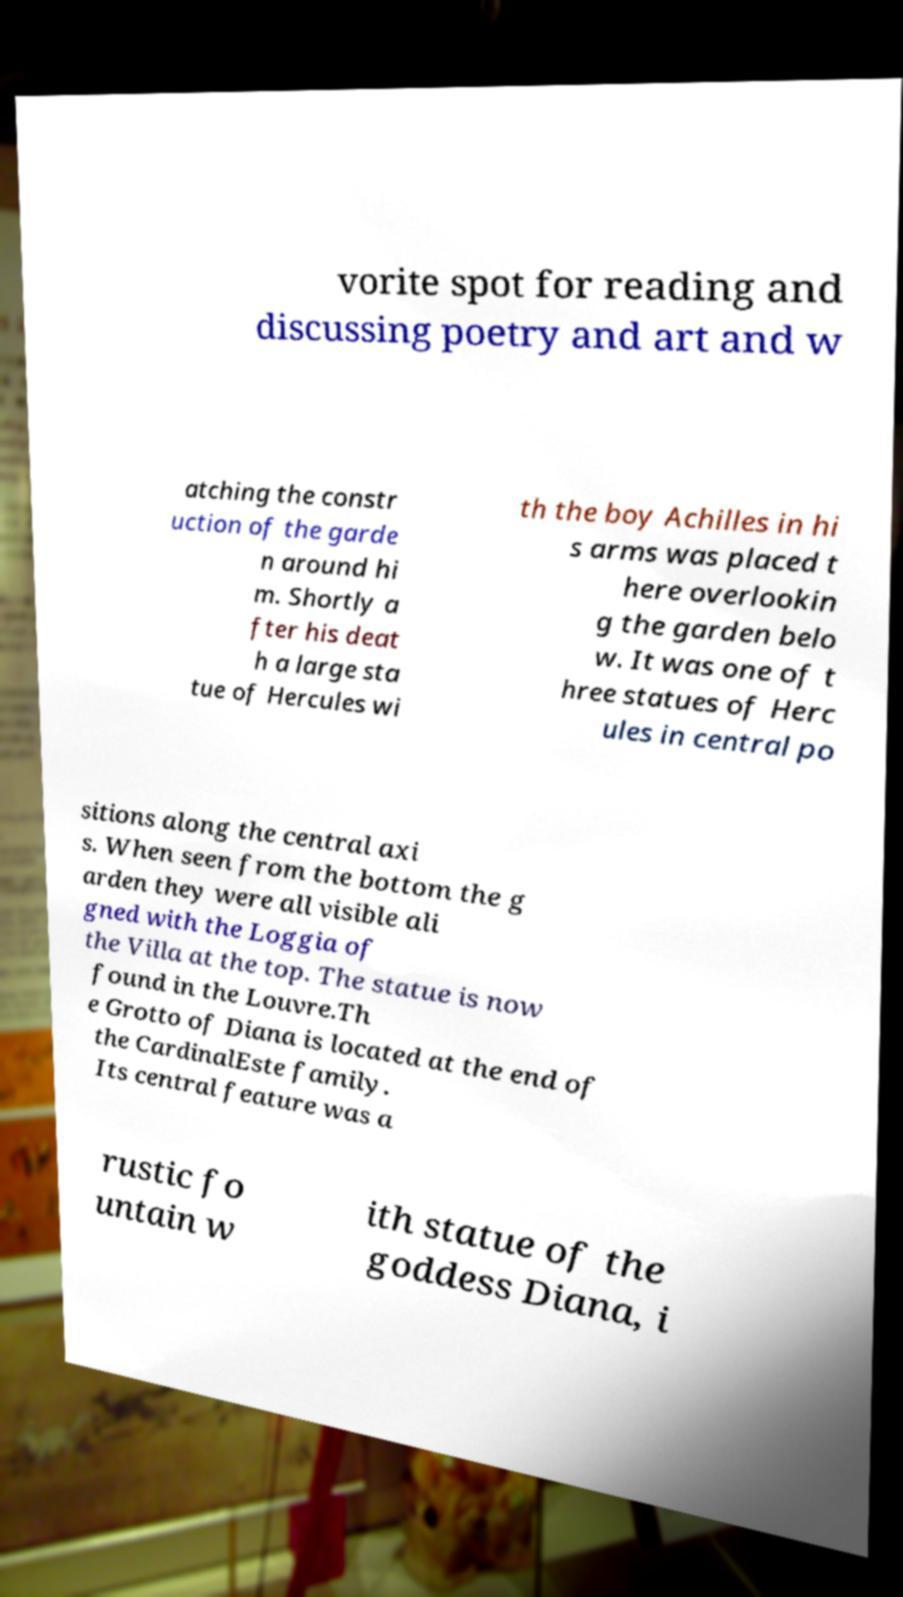Could you extract and type out the text from this image? vorite spot for reading and discussing poetry and art and w atching the constr uction of the garde n around hi m. Shortly a fter his deat h a large sta tue of Hercules wi th the boy Achilles in hi s arms was placed t here overlookin g the garden belo w. It was one of t hree statues of Herc ules in central po sitions along the central axi s. When seen from the bottom the g arden they were all visible ali gned with the Loggia of the Villa at the top. The statue is now found in the Louvre.Th e Grotto of Diana is located at the end of the CardinalEste family. Its central feature was a rustic fo untain w ith statue of the goddess Diana, i 